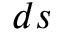<formula> <loc_0><loc_0><loc_500><loc_500>d s</formula> 